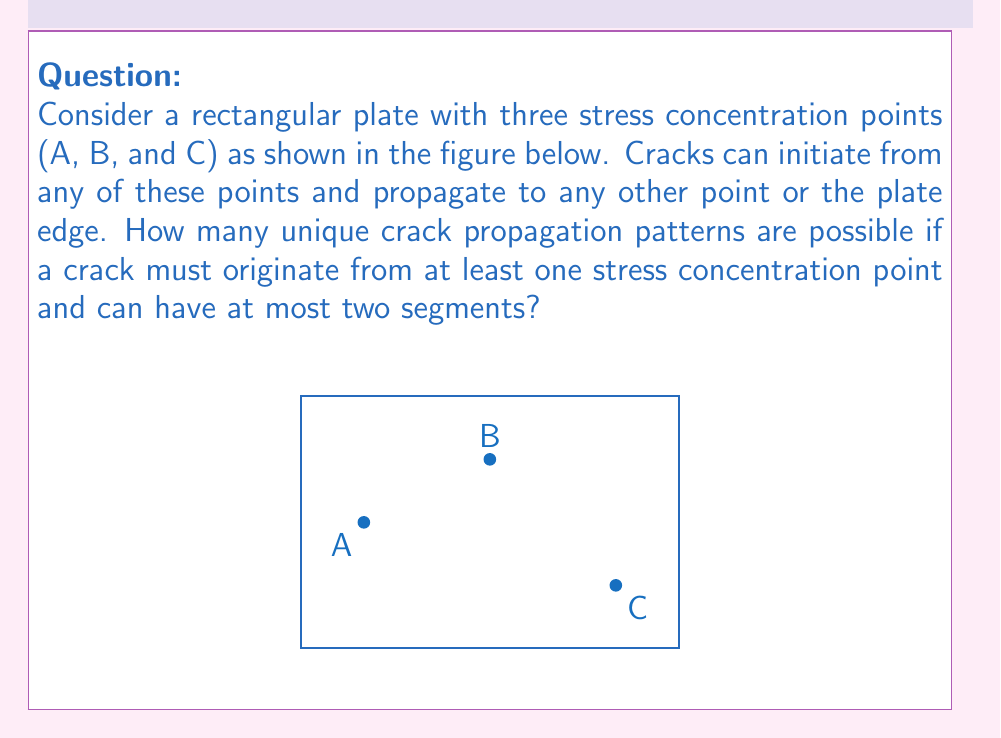Give your solution to this math problem. Let's approach this problem step-by-step:

1) First, we need to consider the possible crack initiation points. We have three stress concentration points: A, B, and C.

2) For each initiation point, we have the following possibilities:
   a) The crack propagates directly to an edge (4 edges).
   b) The crack propagates to another stress concentration point (2 options).
   c) The crack propagates to another stress concentration point and then to an edge (2 * 4 = 8 options).

3) Let's count the patterns for each initiation point:
   - From A: 4 (to edge) + 2 (to B or C) + 8 (to B/C then edge) = 14
   - From B: 4 (to edge) + 2 (to A or C) + 8 (to A/C then edge) = 14
   - From C: 4 (to edge) + 2 (to A or B) + 8 (to A/B then edge) = 14

4) Now, we need to consider patterns starting from multiple points simultaneously:
   - From A and B: 1 (A to B)
   - From A and C: 1 (A to C)
   - From B and C: 1 (B to C)

5) Finally, we have one pattern starting from all three points simultaneously:
   - From A, B, and C: 1 (forming a triangle)

6) The total number of unique patterns is the sum of all these possibilities:
   $$ 14 + 14 + 14 + 1 + 1 + 1 + 1 = 46 $$

Therefore, there are 46 unique crack propagation patterns possible under the given conditions.
Answer: 46 